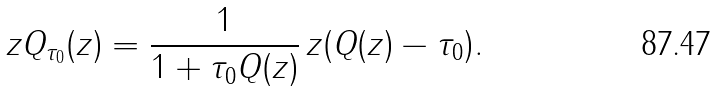Convert formula to latex. <formula><loc_0><loc_0><loc_500><loc_500>z Q _ { \tau _ { 0 } } ( z ) = \frac { 1 } { 1 + \tau _ { 0 } Q ( z ) } \, z ( Q ( z ) - \tau _ { 0 } ) .</formula> 